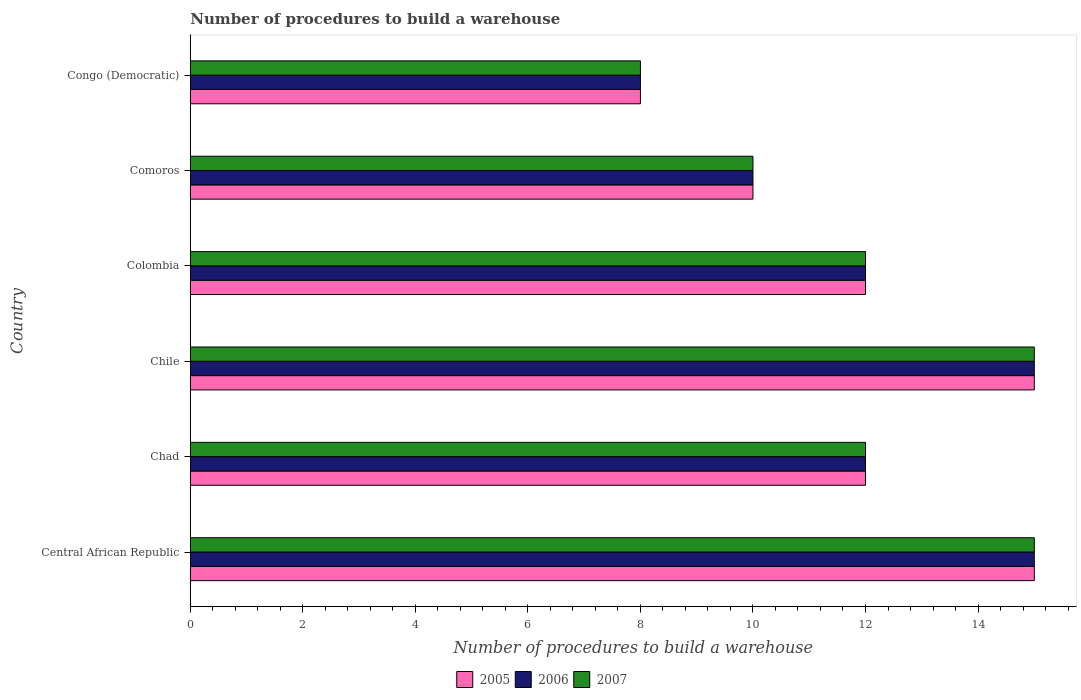Are the number of bars per tick equal to the number of legend labels?
Your answer should be compact. Yes. How many bars are there on the 2nd tick from the top?
Offer a terse response. 3. What is the label of the 6th group of bars from the top?
Offer a terse response. Central African Republic. In how many cases, is the number of bars for a given country not equal to the number of legend labels?
Give a very brief answer. 0. Across all countries, what is the maximum number of procedures to build a warehouse in in 2005?
Provide a succinct answer. 15. In which country was the number of procedures to build a warehouse in in 2007 maximum?
Your response must be concise. Central African Republic. In which country was the number of procedures to build a warehouse in in 2007 minimum?
Your answer should be compact. Congo (Democratic). What is the difference between the number of procedures to build a warehouse in in 2006 in Central African Republic and that in Chile?
Your answer should be compact. 0. What is the difference between the number of procedures to build a warehouse in in 2005 and number of procedures to build a warehouse in in 2007 in Colombia?
Make the answer very short. 0. In how many countries, is the number of procedures to build a warehouse in in 2006 greater than 5.6 ?
Provide a succinct answer. 6. What is the ratio of the number of procedures to build a warehouse in in 2006 in Chad to that in Comoros?
Keep it short and to the point. 1.2. Is the number of procedures to build a warehouse in in 2006 in Chile less than that in Colombia?
Give a very brief answer. No. Is the difference between the number of procedures to build a warehouse in in 2005 in Central African Republic and Comoros greater than the difference between the number of procedures to build a warehouse in in 2007 in Central African Republic and Comoros?
Your answer should be very brief. No. What is the difference between the highest and the second highest number of procedures to build a warehouse in in 2006?
Ensure brevity in your answer.  0. In how many countries, is the number of procedures to build a warehouse in in 2006 greater than the average number of procedures to build a warehouse in in 2006 taken over all countries?
Your answer should be compact. 2. Is the sum of the number of procedures to build a warehouse in in 2005 in Central African Republic and Congo (Democratic) greater than the maximum number of procedures to build a warehouse in in 2007 across all countries?
Make the answer very short. Yes. What does the 2nd bar from the top in Chile represents?
Your answer should be very brief. 2006. Is it the case that in every country, the sum of the number of procedures to build a warehouse in in 2006 and number of procedures to build a warehouse in in 2005 is greater than the number of procedures to build a warehouse in in 2007?
Your answer should be very brief. Yes. Are all the bars in the graph horizontal?
Provide a succinct answer. Yes. How many countries are there in the graph?
Ensure brevity in your answer.  6. How many legend labels are there?
Provide a short and direct response. 3. What is the title of the graph?
Provide a short and direct response. Number of procedures to build a warehouse. What is the label or title of the X-axis?
Ensure brevity in your answer.  Number of procedures to build a warehouse. What is the Number of procedures to build a warehouse of 2005 in Central African Republic?
Offer a terse response. 15. What is the Number of procedures to build a warehouse in 2006 in Central African Republic?
Give a very brief answer. 15. What is the Number of procedures to build a warehouse of 2005 in Chad?
Provide a short and direct response. 12. What is the Number of procedures to build a warehouse in 2006 in Chile?
Give a very brief answer. 15. What is the Number of procedures to build a warehouse in 2007 in Chile?
Your answer should be very brief. 15. What is the Number of procedures to build a warehouse in 2005 in Colombia?
Offer a terse response. 12. What is the Number of procedures to build a warehouse in 2006 in Congo (Democratic)?
Provide a short and direct response. 8. What is the Number of procedures to build a warehouse of 2007 in Congo (Democratic)?
Ensure brevity in your answer.  8. Across all countries, what is the maximum Number of procedures to build a warehouse in 2007?
Your response must be concise. 15. Across all countries, what is the minimum Number of procedures to build a warehouse of 2005?
Keep it short and to the point. 8. Across all countries, what is the minimum Number of procedures to build a warehouse of 2006?
Provide a short and direct response. 8. What is the total Number of procedures to build a warehouse in 2005 in the graph?
Your response must be concise. 72. What is the total Number of procedures to build a warehouse of 2007 in the graph?
Your response must be concise. 72. What is the difference between the Number of procedures to build a warehouse in 2005 in Central African Republic and that in Chad?
Give a very brief answer. 3. What is the difference between the Number of procedures to build a warehouse of 2007 in Central African Republic and that in Chad?
Your answer should be compact. 3. What is the difference between the Number of procedures to build a warehouse in 2005 in Central African Republic and that in Chile?
Your answer should be compact. 0. What is the difference between the Number of procedures to build a warehouse in 2007 in Central African Republic and that in Chile?
Offer a terse response. 0. What is the difference between the Number of procedures to build a warehouse in 2005 in Central African Republic and that in Congo (Democratic)?
Offer a very short reply. 7. What is the difference between the Number of procedures to build a warehouse in 2006 in Central African Republic and that in Congo (Democratic)?
Provide a short and direct response. 7. What is the difference between the Number of procedures to build a warehouse of 2005 in Chad and that in Chile?
Give a very brief answer. -3. What is the difference between the Number of procedures to build a warehouse in 2005 in Chad and that in Colombia?
Keep it short and to the point. 0. What is the difference between the Number of procedures to build a warehouse of 2005 in Chad and that in Comoros?
Offer a very short reply. 2. What is the difference between the Number of procedures to build a warehouse of 2006 in Chad and that in Comoros?
Provide a succinct answer. 2. What is the difference between the Number of procedures to build a warehouse in 2007 in Chad and that in Comoros?
Offer a terse response. 2. What is the difference between the Number of procedures to build a warehouse of 2005 in Chad and that in Congo (Democratic)?
Your answer should be compact. 4. What is the difference between the Number of procedures to build a warehouse in 2006 in Chile and that in Colombia?
Make the answer very short. 3. What is the difference between the Number of procedures to build a warehouse in 2007 in Chile and that in Colombia?
Provide a succinct answer. 3. What is the difference between the Number of procedures to build a warehouse in 2005 in Chile and that in Congo (Democratic)?
Ensure brevity in your answer.  7. What is the difference between the Number of procedures to build a warehouse of 2006 in Chile and that in Congo (Democratic)?
Offer a very short reply. 7. What is the difference between the Number of procedures to build a warehouse in 2007 in Chile and that in Congo (Democratic)?
Make the answer very short. 7. What is the difference between the Number of procedures to build a warehouse of 2006 in Colombia and that in Comoros?
Offer a terse response. 2. What is the difference between the Number of procedures to build a warehouse of 2006 in Colombia and that in Congo (Democratic)?
Provide a short and direct response. 4. What is the difference between the Number of procedures to build a warehouse in 2005 in Comoros and that in Congo (Democratic)?
Give a very brief answer. 2. What is the difference between the Number of procedures to build a warehouse of 2007 in Comoros and that in Congo (Democratic)?
Provide a succinct answer. 2. What is the difference between the Number of procedures to build a warehouse in 2006 in Central African Republic and the Number of procedures to build a warehouse in 2007 in Chad?
Ensure brevity in your answer.  3. What is the difference between the Number of procedures to build a warehouse in 2006 in Central African Republic and the Number of procedures to build a warehouse in 2007 in Chile?
Offer a very short reply. 0. What is the difference between the Number of procedures to build a warehouse in 2006 in Central African Republic and the Number of procedures to build a warehouse in 2007 in Comoros?
Your answer should be compact. 5. What is the difference between the Number of procedures to build a warehouse in 2005 in Central African Republic and the Number of procedures to build a warehouse in 2006 in Congo (Democratic)?
Offer a very short reply. 7. What is the difference between the Number of procedures to build a warehouse of 2005 in Central African Republic and the Number of procedures to build a warehouse of 2007 in Congo (Democratic)?
Keep it short and to the point. 7. What is the difference between the Number of procedures to build a warehouse of 2006 in Chad and the Number of procedures to build a warehouse of 2007 in Chile?
Make the answer very short. -3. What is the difference between the Number of procedures to build a warehouse of 2005 in Chad and the Number of procedures to build a warehouse of 2007 in Colombia?
Keep it short and to the point. 0. What is the difference between the Number of procedures to build a warehouse in 2006 in Chad and the Number of procedures to build a warehouse in 2007 in Colombia?
Make the answer very short. 0. What is the difference between the Number of procedures to build a warehouse of 2006 in Chad and the Number of procedures to build a warehouse of 2007 in Comoros?
Your answer should be very brief. 2. What is the difference between the Number of procedures to build a warehouse in 2005 in Chad and the Number of procedures to build a warehouse in 2006 in Congo (Democratic)?
Keep it short and to the point. 4. What is the difference between the Number of procedures to build a warehouse in 2005 in Chad and the Number of procedures to build a warehouse in 2007 in Congo (Democratic)?
Provide a succinct answer. 4. What is the difference between the Number of procedures to build a warehouse in 2005 in Chile and the Number of procedures to build a warehouse in 2006 in Colombia?
Keep it short and to the point. 3. What is the difference between the Number of procedures to build a warehouse in 2006 in Chile and the Number of procedures to build a warehouse in 2007 in Comoros?
Offer a very short reply. 5. What is the difference between the Number of procedures to build a warehouse in 2005 in Chile and the Number of procedures to build a warehouse in 2006 in Congo (Democratic)?
Keep it short and to the point. 7. What is the difference between the Number of procedures to build a warehouse of 2005 in Chile and the Number of procedures to build a warehouse of 2007 in Congo (Democratic)?
Your response must be concise. 7. What is the difference between the Number of procedures to build a warehouse in 2005 in Colombia and the Number of procedures to build a warehouse in 2006 in Comoros?
Your answer should be compact. 2. What is the difference between the Number of procedures to build a warehouse of 2005 in Colombia and the Number of procedures to build a warehouse of 2007 in Comoros?
Your answer should be compact. 2. What is the difference between the Number of procedures to build a warehouse of 2006 in Colombia and the Number of procedures to build a warehouse of 2007 in Comoros?
Provide a succinct answer. 2. What is the difference between the Number of procedures to build a warehouse of 2005 in Colombia and the Number of procedures to build a warehouse of 2006 in Congo (Democratic)?
Keep it short and to the point. 4. What is the difference between the Number of procedures to build a warehouse in 2005 in Comoros and the Number of procedures to build a warehouse in 2006 in Congo (Democratic)?
Offer a terse response. 2. What is the difference between the Number of procedures to build a warehouse in 2005 in Comoros and the Number of procedures to build a warehouse in 2007 in Congo (Democratic)?
Offer a terse response. 2. What is the average Number of procedures to build a warehouse of 2006 per country?
Give a very brief answer. 12. What is the difference between the Number of procedures to build a warehouse of 2005 and Number of procedures to build a warehouse of 2007 in Central African Republic?
Provide a succinct answer. 0. What is the difference between the Number of procedures to build a warehouse of 2005 and Number of procedures to build a warehouse of 2006 in Chad?
Offer a terse response. 0. What is the difference between the Number of procedures to build a warehouse in 2005 and Number of procedures to build a warehouse in 2007 in Chad?
Provide a short and direct response. 0. What is the difference between the Number of procedures to build a warehouse in 2005 and Number of procedures to build a warehouse in 2007 in Chile?
Ensure brevity in your answer.  0. What is the difference between the Number of procedures to build a warehouse of 2005 and Number of procedures to build a warehouse of 2006 in Colombia?
Provide a short and direct response. 0. What is the difference between the Number of procedures to build a warehouse in 2005 and Number of procedures to build a warehouse in 2007 in Colombia?
Make the answer very short. 0. What is the difference between the Number of procedures to build a warehouse in 2005 and Number of procedures to build a warehouse in 2006 in Comoros?
Offer a terse response. 0. What is the difference between the Number of procedures to build a warehouse of 2005 and Number of procedures to build a warehouse of 2007 in Comoros?
Provide a short and direct response. 0. What is the difference between the Number of procedures to build a warehouse of 2006 and Number of procedures to build a warehouse of 2007 in Comoros?
Provide a succinct answer. 0. What is the difference between the Number of procedures to build a warehouse in 2005 and Number of procedures to build a warehouse in 2007 in Congo (Democratic)?
Your answer should be compact. 0. What is the difference between the Number of procedures to build a warehouse in 2006 and Number of procedures to build a warehouse in 2007 in Congo (Democratic)?
Make the answer very short. 0. What is the ratio of the Number of procedures to build a warehouse of 2005 in Central African Republic to that in Chile?
Your answer should be very brief. 1. What is the ratio of the Number of procedures to build a warehouse of 2006 in Central African Republic to that in Chile?
Your response must be concise. 1. What is the ratio of the Number of procedures to build a warehouse of 2007 in Central African Republic to that in Chile?
Provide a succinct answer. 1. What is the ratio of the Number of procedures to build a warehouse in 2005 in Central African Republic to that in Colombia?
Make the answer very short. 1.25. What is the ratio of the Number of procedures to build a warehouse of 2006 in Central African Republic to that in Colombia?
Your response must be concise. 1.25. What is the ratio of the Number of procedures to build a warehouse in 2007 in Central African Republic to that in Colombia?
Provide a short and direct response. 1.25. What is the ratio of the Number of procedures to build a warehouse in 2005 in Central African Republic to that in Comoros?
Keep it short and to the point. 1.5. What is the ratio of the Number of procedures to build a warehouse in 2005 in Central African Republic to that in Congo (Democratic)?
Provide a short and direct response. 1.88. What is the ratio of the Number of procedures to build a warehouse of 2006 in Central African Republic to that in Congo (Democratic)?
Ensure brevity in your answer.  1.88. What is the ratio of the Number of procedures to build a warehouse in 2007 in Central African Republic to that in Congo (Democratic)?
Offer a terse response. 1.88. What is the ratio of the Number of procedures to build a warehouse in 2006 in Chad to that in Chile?
Give a very brief answer. 0.8. What is the ratio of the Number of procedures to build a warehouse of 2005 in Chad to that in Colombia?
Your answer should be compact. 1. What is the ratio of the Number of procedures to build a warehouse of 2005 in Chad to that in Comoros?
Your answer should be very brief. 1.2. What is the ratio of the Number of procedures to build a warehouse of 2007 in Chad to that in Comoros?
Offer a terse response. 1.2. What is the ratio of the Number of procedures to build a warehouse in 2005 in Chad to that in Congo (Democratic)?
Your response must be concise. 1.5. What is the ratio of the Number of procedures to build a warehouse of 2006 in Chad to that in Congo (Democratic)?
Give a very brief answer. 1.5. What is the ratio of the Number of procedures to build a warehouse in 2007 in Chad to that in Congo (Democratic)?
Ensure brevity in your answer.  1.5. What is the ratio of the Number of procedures to build a warehouse of 2005 in Chile to that in Colombia?
Give a very brief answer. 1.25. What is the ratio of the Number of procedures to build a warehouse of 2007 in Chile to that in Colombia?
Your answer should be very brief. 1.25. What is the ratio of the Number of procedures to build a warehouse of 2005 in Chile to that in Comoros?
Offer a terse response. 1.5. What is the ratio of the Number of procedures to build a warehouse in 2007 in Chile to that in Comoros?
Your answer should be very brief. 1.5. What is the ratio of the Number of procedures to build a warehouse of 2005 in Chile to that in Congo (Democratic)?
Your response must be concise. 1.88. What is the ratio of the Number of procedures to build a warehouse of 2006 in Chile to that in Congo (Democratic)?
Give a very brief answer. 1.88. What is the ratio of the Number of procedures to build a warehouse of 2007 in Chile to that in Congo (Democratic)?
Offer a terse response. 1.88. What is the ratio of the Number of procedures to build a warehouse of 2006 in Colombia to that in Comoros?
Your answer should be compact. 1.2. What is the ratio of the Number of procedures to build a warehouse in 2005 in Colombia to that in Congo (Democratic)?
Offer a terse response. 1.5. What is the ratio of the Number of procedures to build a warehouse of 2006 in Colombia to that in Congo (Democratic)?
Ensure brevity in your answer.  1.5. What is the ratio of the Number of procedures to build a warehouse in 2007 in Colombia to that in Congo (Democratic)?
Your answer should be very brief. 1.5. What is the ratio of the Number of procedures to build a warehouse of 2006 in Comoros to that in Congo (Democratic)?
Your answer should be compact. 1.25. What is the difference between the highest and the second highest Number of procedures to build a warehouse in 2005?
Keep it short and to the point. 0. What is the difference between the highest and the second highest Number of procedures to build a warehouse in 2006?
Offer a terse response. 0. What is the difference between the highest and the lowest Number of procedures to build a warehouse of 2007?
Provide a short and direct response. 7. 